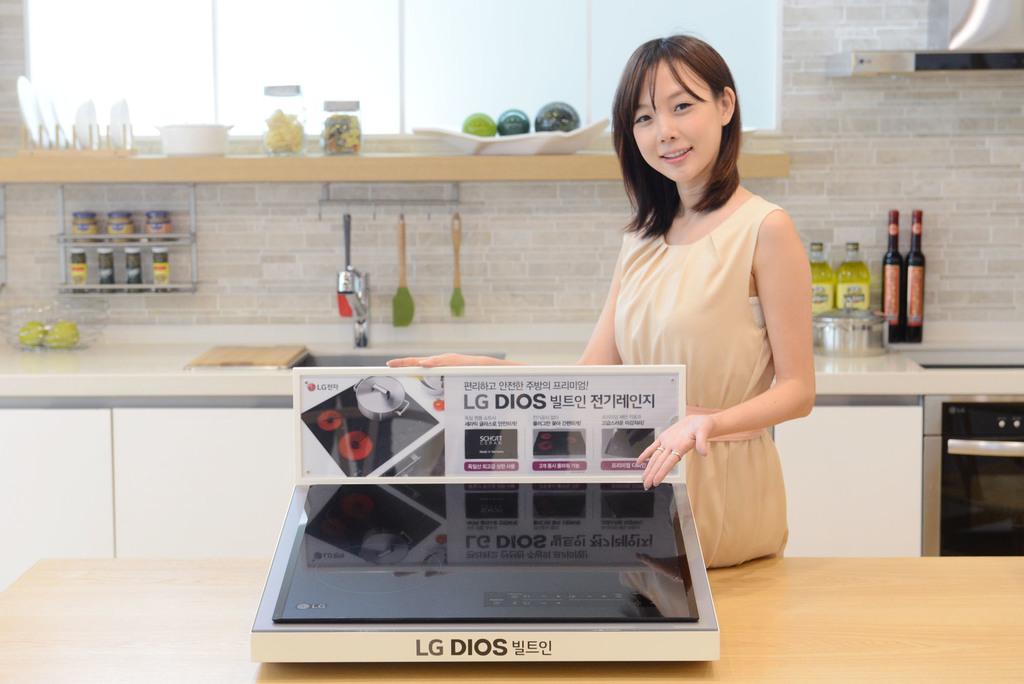What company makes this product?
Give a very brief answer. Lg. What is the model name of this appliance?
Your answer should be very brief. Lg dios. 